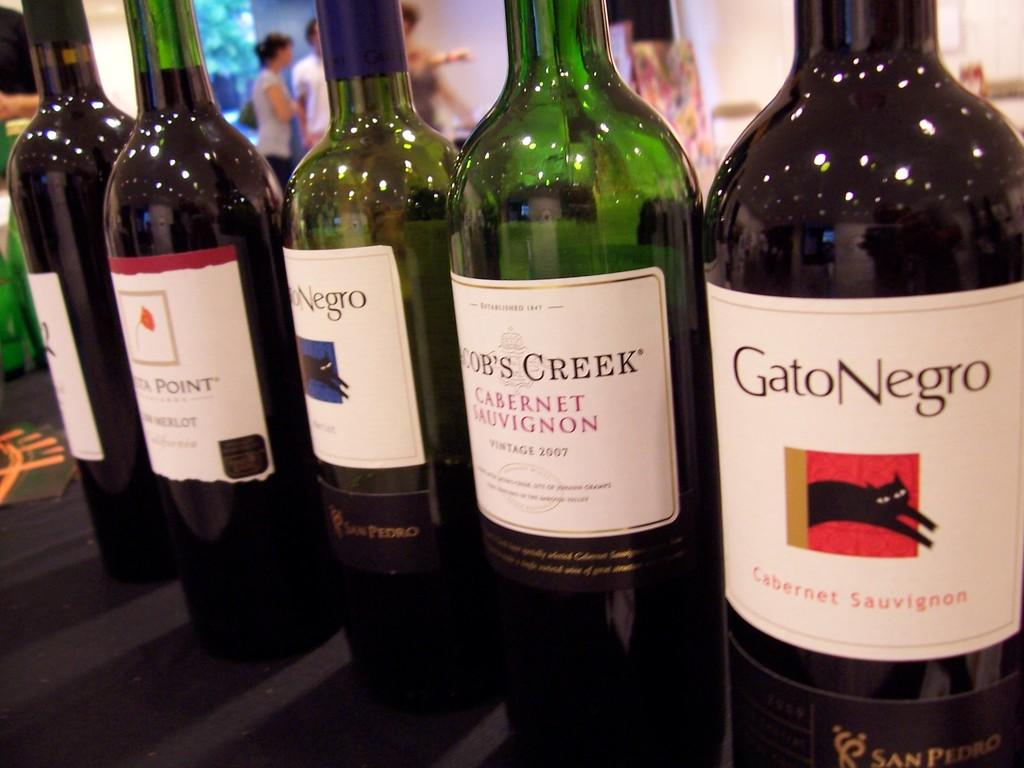<image>
Provide a brief description of the given image. Gato Negro bottle lined up with other bottles. 